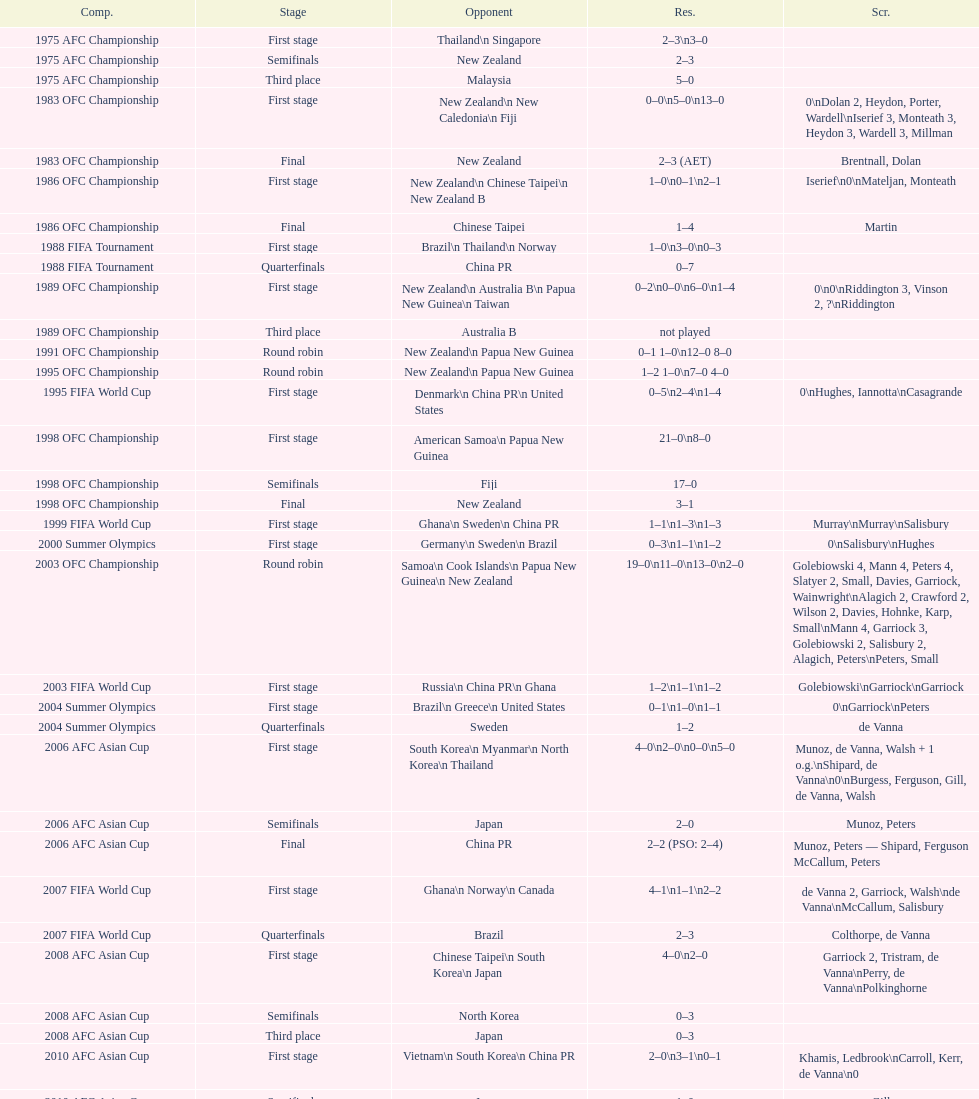In the 1983 ofc championship, how many goals were made in total? 18. 